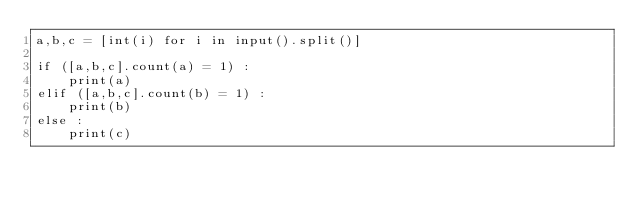<code> <loc_0><loc_0><loc_500><loc_500><_Python_>a,b,c = [int(i) for i in input().split()]

if ([a,b,c].count(a) = 1) :
	print(a)
elif ([a,b,c].count(b) = 1) :
	print(b)
else :
	print(c)
</code> 